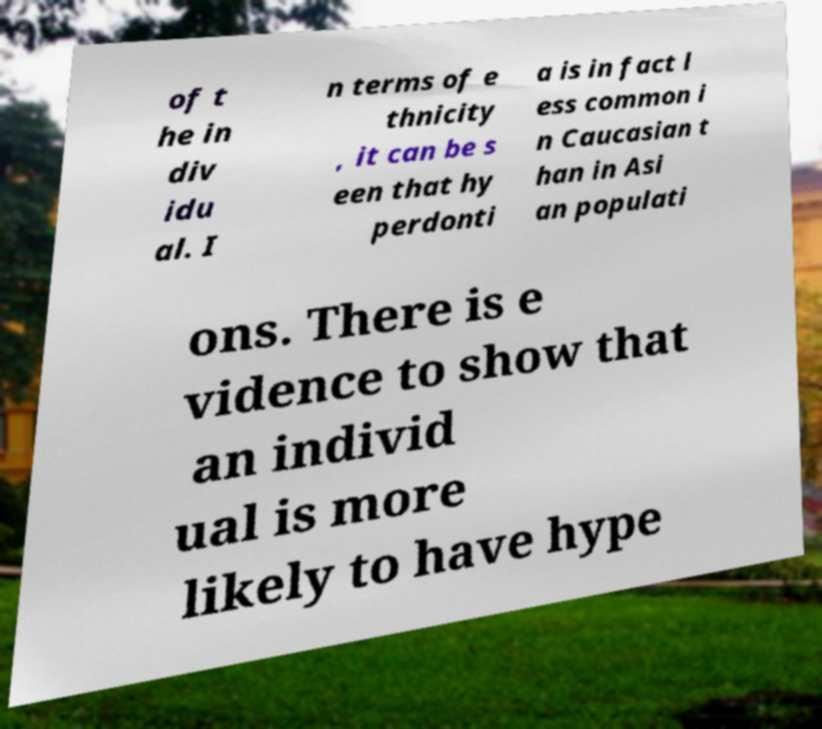Could you assist in decoding the text presented in this image and type it out clearly? of t he in div idu al. I n terms of e thnicity , it can be s een that hy perdonti a is in fact l ess common i n Caucasian t han in Asi an populati ons. There is e vidence to show that an individ ual is more likely to have hype 